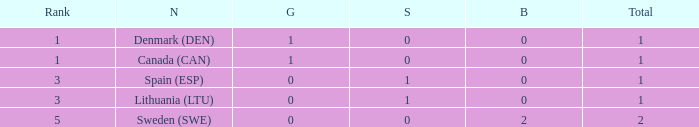What is the rank when there was less than 1 gold, 0 bronze, and more than 1 total? None. Could you help me parse every detail presented in this table? {'header': ['Rank', 'N', 'G', 'S', 'B', 'Total'], 'rows': [['1', 'Denmark (DEN)', '1', '0', '0', '1'], ['1', 'Canada (CAN)', '1', '0', '0', '1'], ['3', 'Spain (ESP)', '0', '1', '0', '1'], ['3', 'Lithuania (LTU)', '0', '1', '0', '1'], ['5', 'Sweden (SWE)', '0', '0', '2', '2']]} 